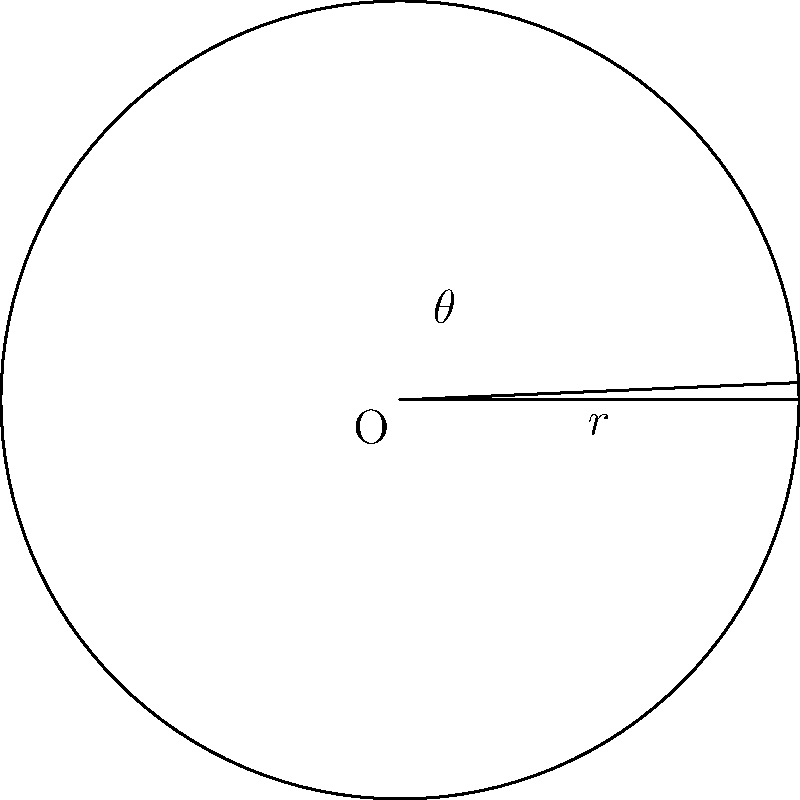In a Kubernetes cluster monitoring system, you're designing a circular dashboard to represent resource utilization. Given a circular sector with radius $r = 5$ units and central angle $\theta = 1.2$ radians, calculate the area of this sector. Round your answer to two decimal places. To find the area of a circular sector, we can follow these steps:

1. Recall the formula for the area of a circular sector:
   $$A = \frac{1}{2} r^2 \theta$$
   Where $A$ is the area, $r$ is the radius, and $\theta$ is the central angle in radians.

2. Substitute the given values:
   $r = 5$ units
   $\theta = 1.2$ radians

3. Calculate the area:
   $$A = \frac{1}{2} \cdot 5^2 \cdot 1.2$$
   $$A = \frac{1}{2} \cdot 25 \cdot 1.2$$
   $$A = 12.5 \cdot 1.2$$
   $$A = 15$$

4. Round the result to two decimal places:
   $A \approx 15.00$ square units

This calculation could represent, for example, the proportion of CPU or memory usage in a specific node or pod within your Kubernetes cluster.
Answer: 15.00 square units 